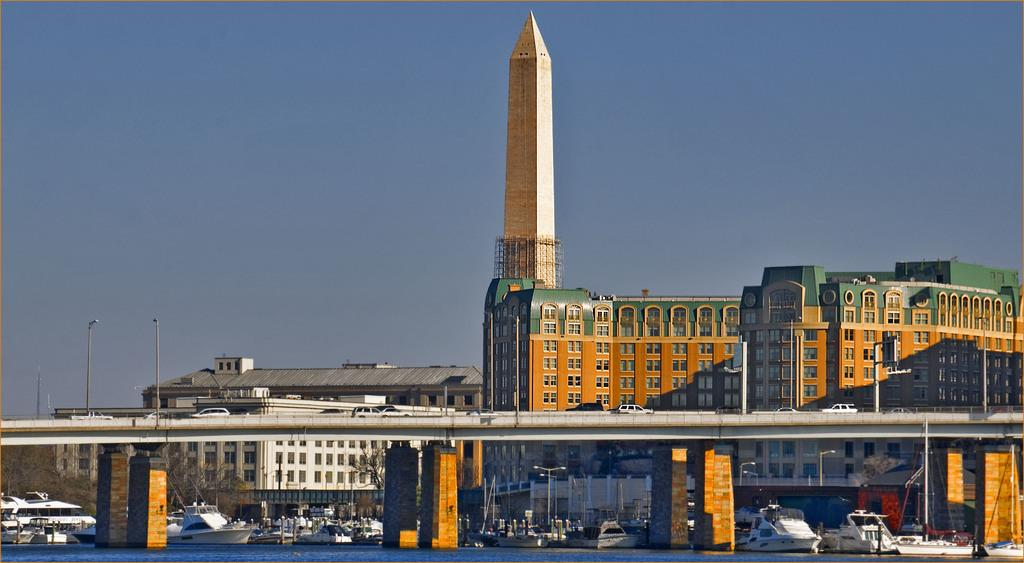What type of structures can be seen in the image? There are buildings with windows in the image. What type of transportation infrastructure is present in the image? There is a bridge in the image. What types of vehicles are visible in the image? Vehicles are present in the image. What type of watercraft can be seen in the image? Boats are visible in the image. What type of vegetation is present in the image? Trees are present in the image. What type of street furniture is visible in the image? Light poles are in the image. What is visible in the background of the image? The sky is visible in the background of the image. Can you tell me how many toads are sitting on the bridge in the image? There are no toads present in the image; it features buildings, a bridge, vehicles, boats, trees, light poles, and the sky. What type of plane can be seen flying over the buildings in the image? There is no plane visible in the image; it only features buildings, a bridge, vehicles, boats, trees, light poles, and the sky. 